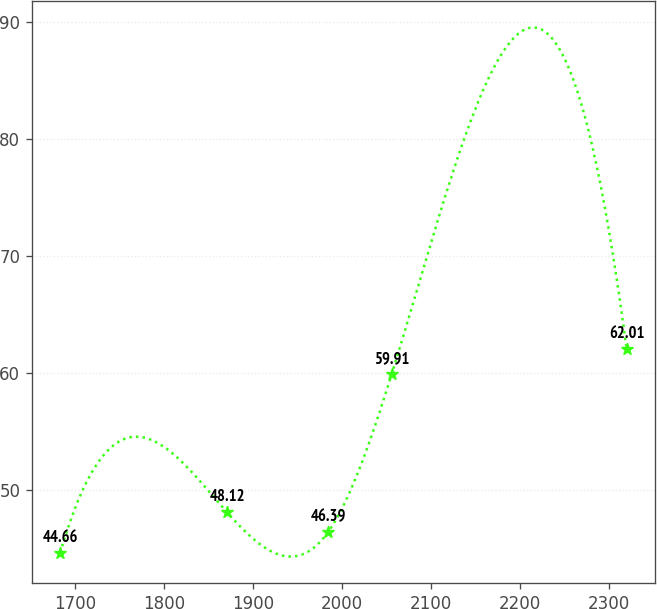<chart> <loc_0><loc_0><loc_500><loc_500><line_chart><ecel><fcel>Unnamed: 1<nl><fcel>1683.24<fcel>44.66<nl><fcel>1870.61<fcel>48.12<nl><fcel>1984.15<fcel>46.39<nl><fcel>2055.97<fcel>59.91<nl><fcel>2320.02<fcel>62.01<nl></chart> 